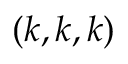<formula> <loc_0><loc_0><loc_500><loc_500>( k , k , k )</formula> 